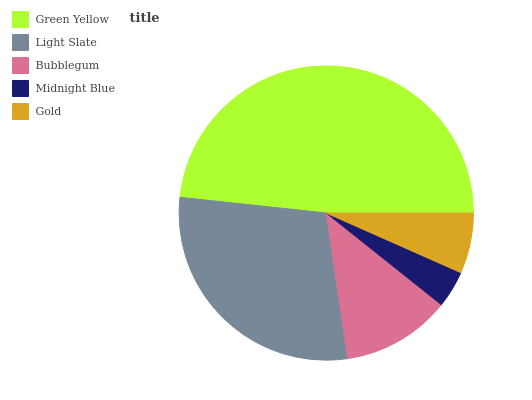Is Midnight Blue the minimum?
Answer yes or no. Yes. Is Green Yellow the maximum?
Answer yes or no. Yes. Is Light Slate the minimum?
Answer yes or no. No. Is Light Slate the maximum?
Answer yes or no. No. Is Green Yellow greater than Light Slate?
Answer yes or no. Yes. Is Light Slate less than Green Yellow?
Answer yes or no. Yes. Is Light Slate greater than Green Yellow?
Answer yes or no. No. Is Green Yellow less than Light Slate?
Answer yes or no. No. Is Bubblegum the high median?
Answer yes or no. Yes. Is Bubblegum the low median?
Answer yes or no. Yes. Is Light Slate the high median?
Answer yes or no. No. Is Light Slate the low median?
Answer yes or no. No. 